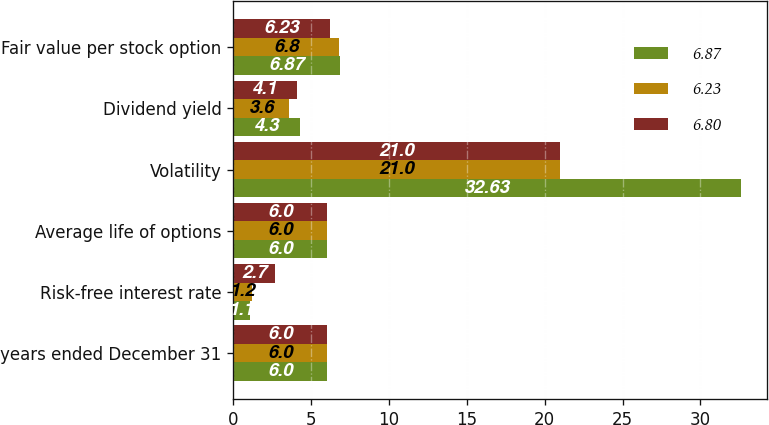Convert chart to OTSL. <chart><loc_0><loc_0><loc_500><loc_500><stacked_bar_chart><ecel><fcel>years ended December 31<fcel>Risk-free interest rate<fcel>Average life of options<fcel>Volatility<fcel>Dividend yield<fcel>Fair value per stock option<nl><fcel>6.87<fcel>6<fcel>1.1<fcel>6<fcel>32.63<fcel>4.3<fcel>6.87<nl><fcel>6.23<fcel>6<fcel>1.2<fcel>6<fcel>21<fcel>3.6<fcel>6.8<nl><fcel>6.8<fcel>6<fcel>2.7<fcel>6<fcel>21<fcel>4.1<fcel>6.23<nl></chart> 